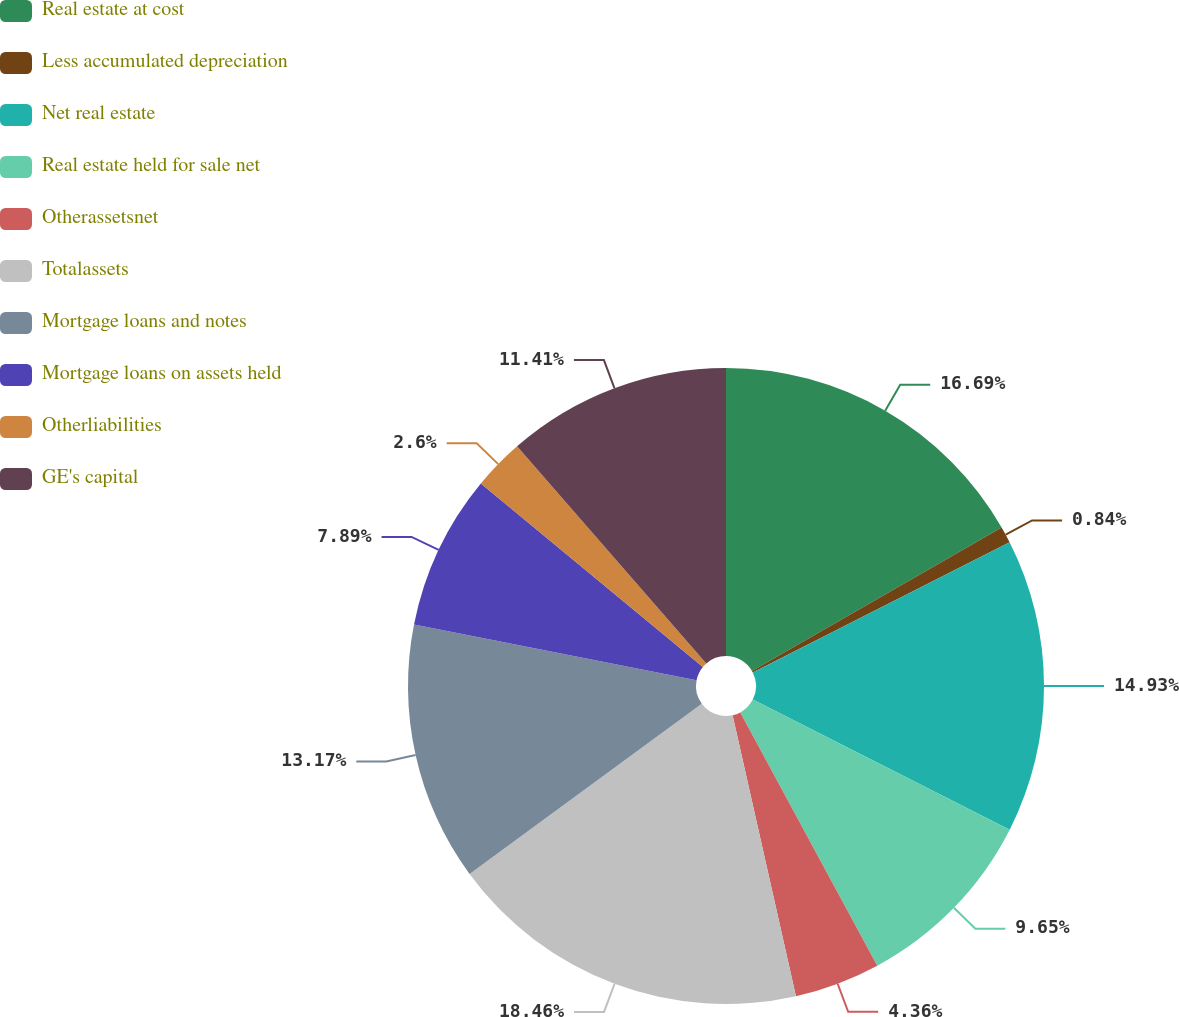Convert chart. <chart><loc_0><loc_0><loc_500><loc_500><pie_chart><fcel>Real estate at cost<fcel>Less accumulated depreciation<fcel>Net real estate<fcel>Real estate held for sale net<fcel>Otherassetsnet<fcel>Totalassets<fcel>Mortgage loans and notes<fcel>Mortgage loans on assets held<fcel>Otherliabilities<fcel>GE's capital<nl><fcel>16.69%<fcel>0.84%<fcel>14.93%<fcel>9.65%<fcel>4.36%<fcel>18.46%<fcel>13.17%<fcel>7.89%<fcel>2.6%<fcel>11.41%<nl></chart> 